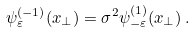Convert formula to latex. <formula><loc_0><loc_0><loc_500><loc_500>\psi _ { \varepsilon } ^ { ( - 1 ) } ( x _ { \perp } ) = \sigma ^ { 2 } \psi _ { - \varepsilon } ^ { ( 1 ) } ( x _ { \perp } ) \, .</formula> 